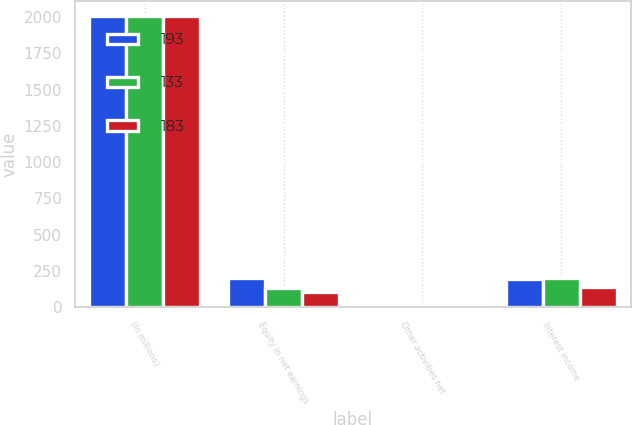Convert chart. <chart><loc_0><loc_0><loc_500><loc_500><stacked_bar_chart><ecel><fcel>(In millions)<fcel>Equity in net earnings<fcel>Other activities net<fcel>Interest income<nl><fcel>193<fcel>2007<fcel>203<fcel>19<fcel>193<nl><fcel>133<fcel>2006<fcel>130<fcel>24<fcel>199<nl><fcel>183<fcel>2005<fcel>108<fcel>5<fcel>143<nl></chart> 